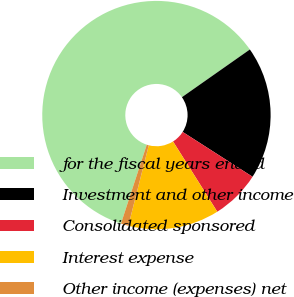Convert chart to OTSL. <chart><loc_0><loc_0><loc_500><loc_500><pie_chart><fcel>for the fiscal years ended<fcel>Investment and other income<fcel>Consolidated sponsored<fcel>Interest expense<fcel>Other income (expenses) net<nl><fcel>60.23%<fcel>18.82%<fcel>6.98%<fcel>12.9%<fcel>1.07%<nl></chart> 